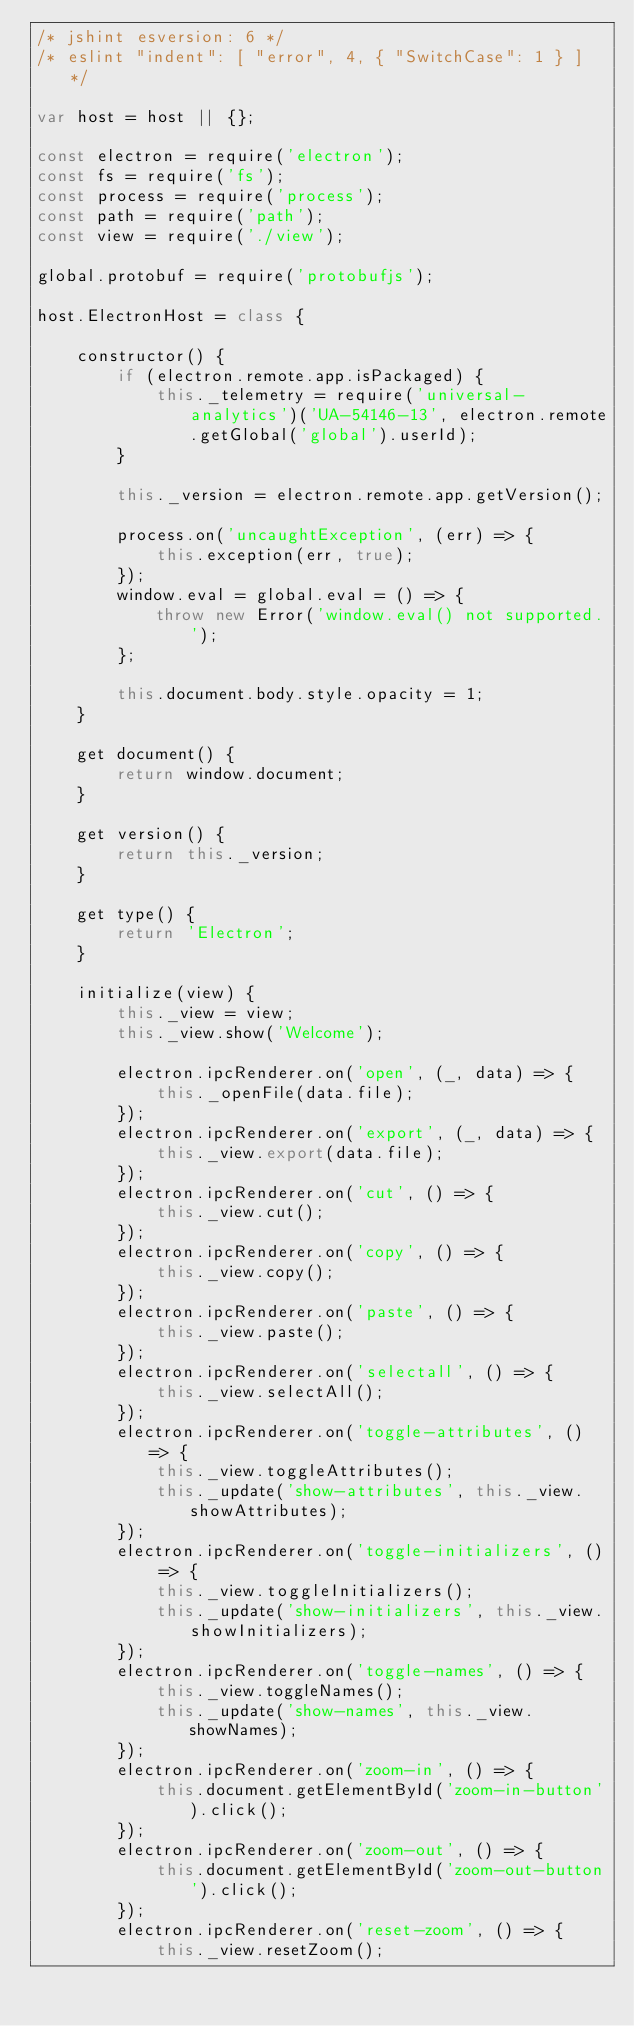<code> <loc_0><loc_0><loc_500><loc_500><_JavaScript_>/* jshint esversion: 6 */
/* eslint "indent": [ "error", 4, { "SwitchCase": 1 } ] */

var host = host || {};

const electron = require('electron');
const fs = require('fs');
const process = require('process');
const path = require('path');
const view = require('./view');

global.protobuf = require('protobufjs');

host.ElectronHost = class {

    constructor() {
        if (electron.remote.app.isPackaged) {
            this._telemetry = require('universal-analytics')('UA-54146-13', electron.remote.getGlobal('global').userId);
        }

        this._version = electron.remote.app.getVersion();

        process.on('uncaughtException', (err) => {
            this.exception(err, true);
        });
        window.eval = global.eval = () => {
            throw new Error('window.eval() not supported.');
        };

        this.document.body.style.opacity = 1;
    }

    get document() {
        return window.document;
    }

    get version() {
        return this._version;
    }

    get type() {
        return 'Electron';
    }

    initialize(view) {
        this._view = view;
        this._view.show('Welcome');

        electron.ipcRenderer.on('open', (_, data) => {
            this._openFile(data.file);
        });
        electron.ipcRenderer.on('export', (_, data) => {
            this._view.export(data.file);
        });
        electron.ipcRenderer.on('cut', () => {
            this._view.cut();
        });
        electron.ipcRenderer.on('copy', () => {
            this._view.copy();
        });
        electron.ipcRenderer.on('paste', () => {
            this._view.paste();
        });
        electron.ipcRenderer.on('selectall', () => {
            this._view.selectAll();
        });
        electron.ipcRenderer.on('toggle-attributes', () => {
            this._view.toggleAttributes();
            this._update('show-attributes', this._view.showAttributes);
        });
        electron.ipcRenderer.on('toggle-initializers', () => {
            this._view.toggleInitializers();
            this._update('show-initializers', this._view.showInitializers);
        });
        electron.ipcRenderer.on('toggle-names', () => {
            this._view.toggleNames();
            this._update('show-names', this._view.showNames);
        });
        electron.ipcRenderer.on('zoom-in', () => {
            this.document.getElementById('zoom-in-button').click();
        });
        electron.ipcRenderer.on('zoom-out', () => {
            this.document.getElementById('zoom-out-button').click();
        });
        electron.ipcRenderer.on('reset-zoom', () => {
            this._view.resetZoom();</code> 